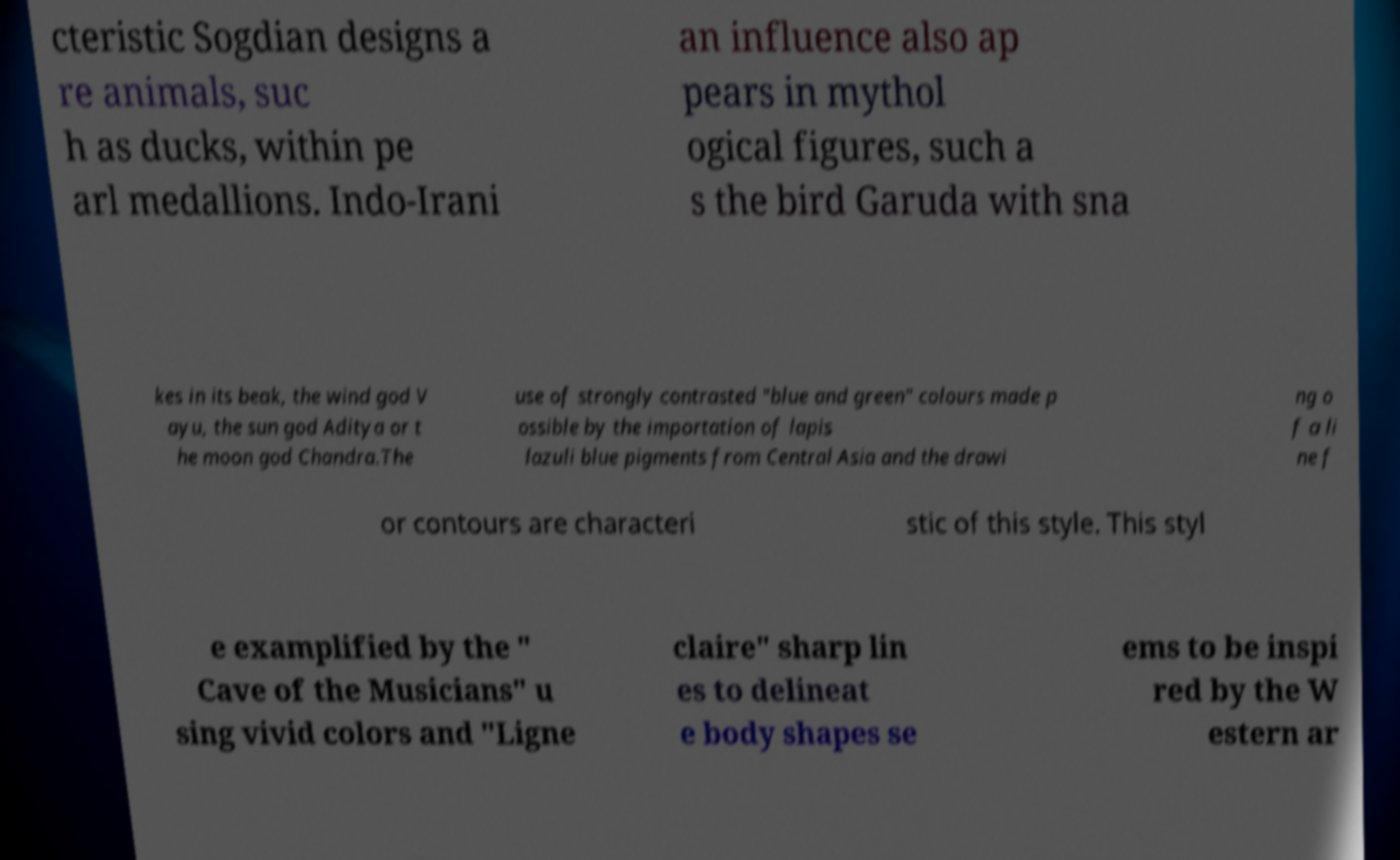I need the written content from this picture converted into text. Can you do that? cteristic Sogdian designs a re animals, suc h as ducks, within pe arl medallions. Indo-Irani an influence also ap pears in mythol ogical figures, such a s the bird Garuda with sna kes in its beak, the wind god V ayu, the sun god Aditya or t he moon god Chandra.The use of strongly contrasted "blue and green" colours made p ossible by the importation of lapis lazuli blue pigments from Central Asia and the drawi ng o f a li ne f or contours are characteri stic of this style. This styl e examplified by the " Cave of the Musicians" u sing vivid colors and "Ligne claire" sharp lin es to delineat e body shapes se ems to be inspi red by the W estern ar 